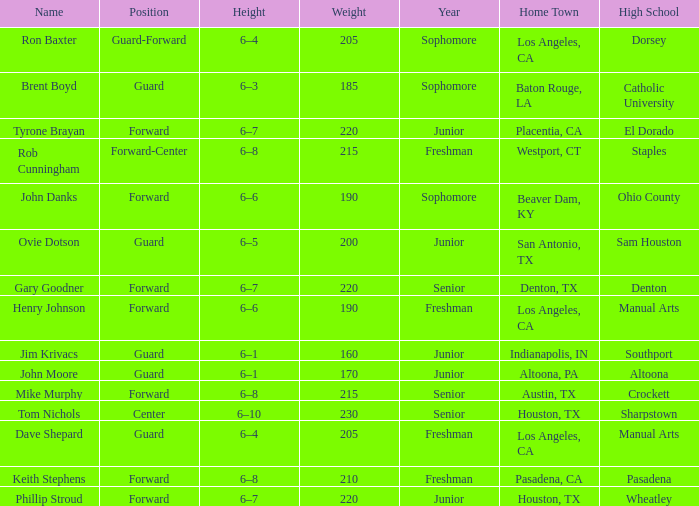What is the Name with a Year of junior, and a High School with wheatley? Phillip Stroud. 